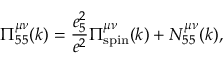<formula> <loc_0><loc_0><loc_500><loc_500>\Pi _ { 5 5 } ^ { \mu \nu } ( k ) = { \frac { e _ { 5 } ^ { 2 } } { e ^ { 2 } } } \Pi _ { s p i n } ^ { \mu \nu } ( k ) + N _ { 5 5 } ^ { \mu \nu } ( k ) ,</formula> 